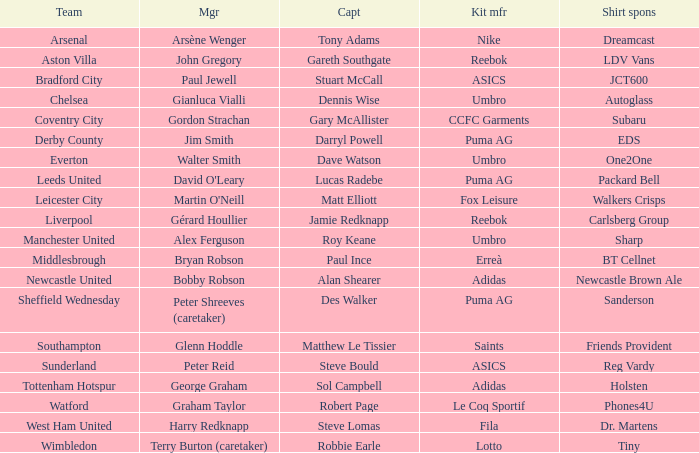Which team is managed by david o'leary? Leeds United. 